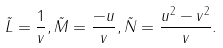Convert formula to latex. <formula><loc_0><loc_0><loc_500><loc_500>\tilde { L } = \frac { 1 } { v } , \tilde { M } = \frac { - u } { v } , \tilde { N } = \frac { u ^ { 2 } - v ^ { 2 } } { v } .</formula> 